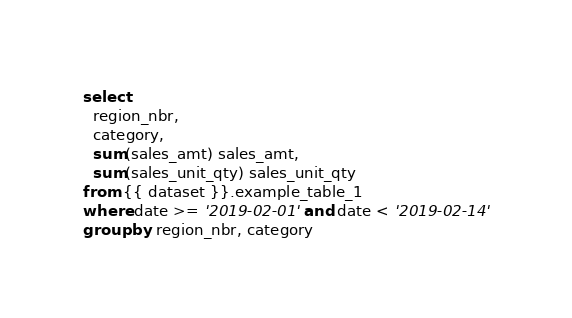<code> <loc_0><loc_0><loc_500><loc_500><_SQL_>select
  region_nbr,
  category,
  sum(sales_amt) sales_amt,
  sum(sales_unit_qty) sales_unit_qty
from {{ dataset }}.example_table_1
where date >= '2019-02-01' and date < '2019-02-14'
group by region_nbr, category</code> 